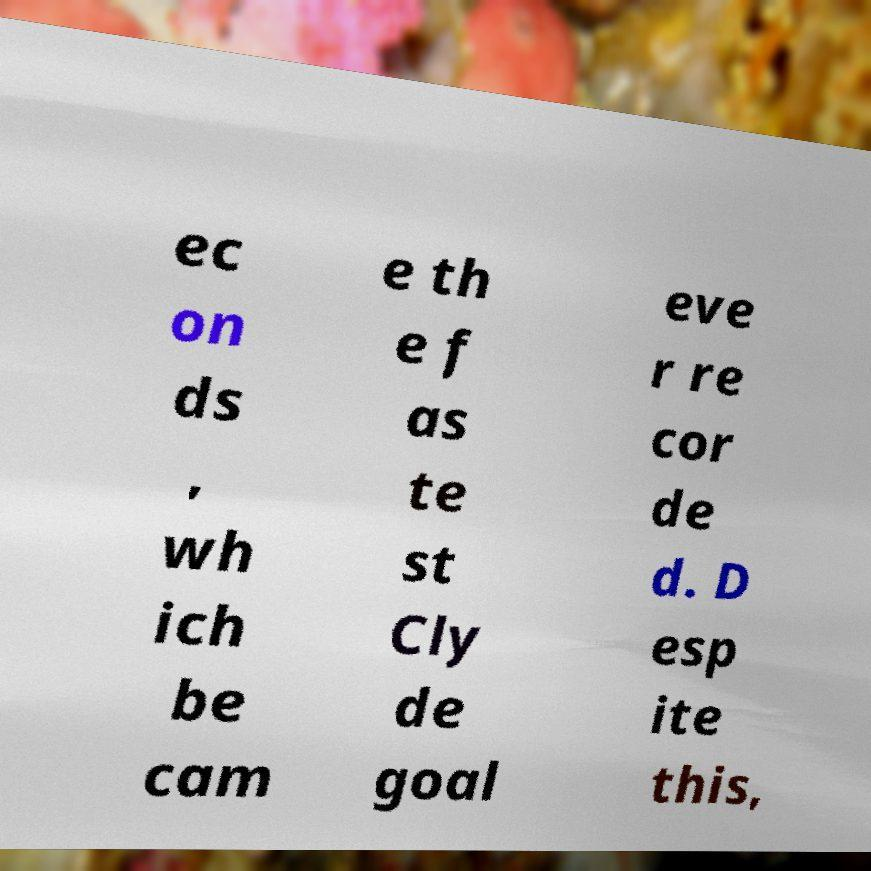There's text embedded in this image that I need extracted. Can you transcribe it verbatim? ec on ds , wh ich be cam e th e f as te st Cly de goal eve r re cor de d. D esp ite this, 